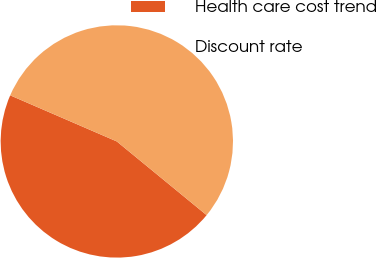Convert chart to OTSL. <chart><loc_0><loc_0><loc_500><loc_500><pie_chart><fcel>Health care cost trend<fcel>Discount rate<nl><fcel>45.56%<fcel>54.44%<nl></chart> 